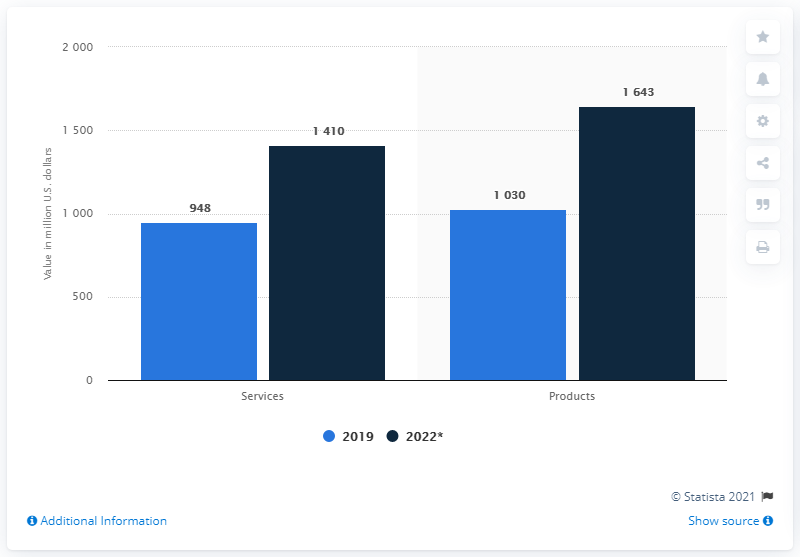List a handful of essential elements in this visual. In 2022, the ratio between services and products was 0.8333333333333333. The chart shows two categories: Services and Products. The cyber security services market in India was valued at approximately 948 million in 2019. 